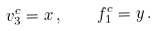Convert formula to latex. <formula><loc_0><loc_0><loc_500><loc_500>v _ { 3 } ^ { c } = x \, , \quad f _ { 1 } ^ { c } = y \, .</formula> 